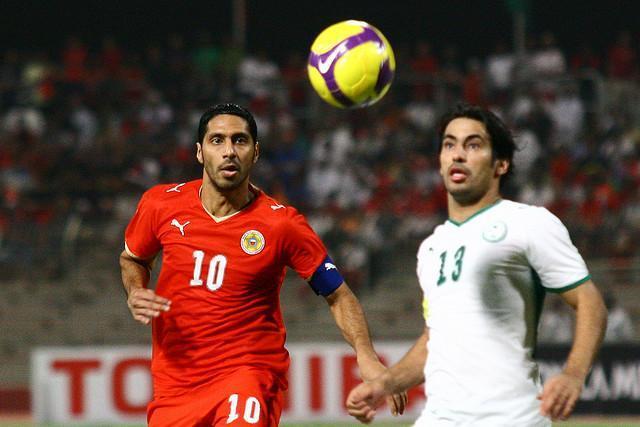How many people are in the picture?
Give a very brief answer. 2. 